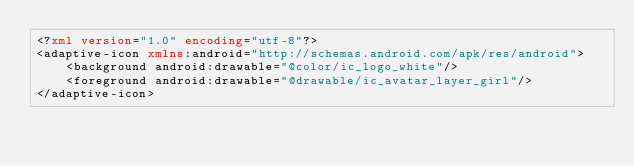<code> <loc_0><loc_0><loc_500><loc_500><_XML_><?xml version="1.0" encoding="utf-8"?>
<adaptive-icon xmlns:android="http://schemas.android.com/apk/res/android">
    <background android:drawable="@color/ic_logo_white"/>
    <foreground android:drawable="@drawable/ic_avatar_layer_girl"/>
</adaptive-icon></code> 